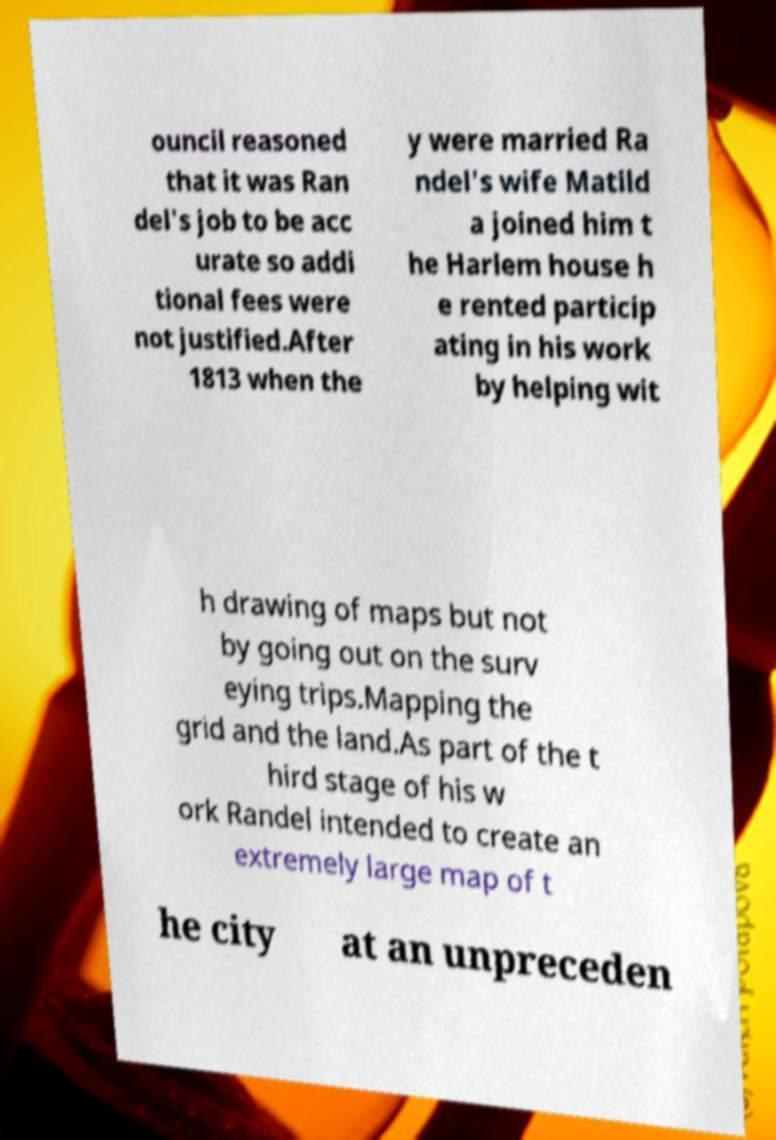Can you read and provide the text displayed in the image?This photo seems to have some interesting text. Can you extract and type it out for me? ouncil reasoned that it was Ran del's job to be acc urate so addi tional fees were not justified.After 1813 when the y were married Ra ndel's wife Matild a joined him t he Harlem house h e rented particip ating in his work by helping wit h drawing of maps but not by going out on the surv eying trips.Mapping the grid and the land.As part of the t hird stage of his w ork Randel intended to create an extremely large map of t he city at an unpreceden 